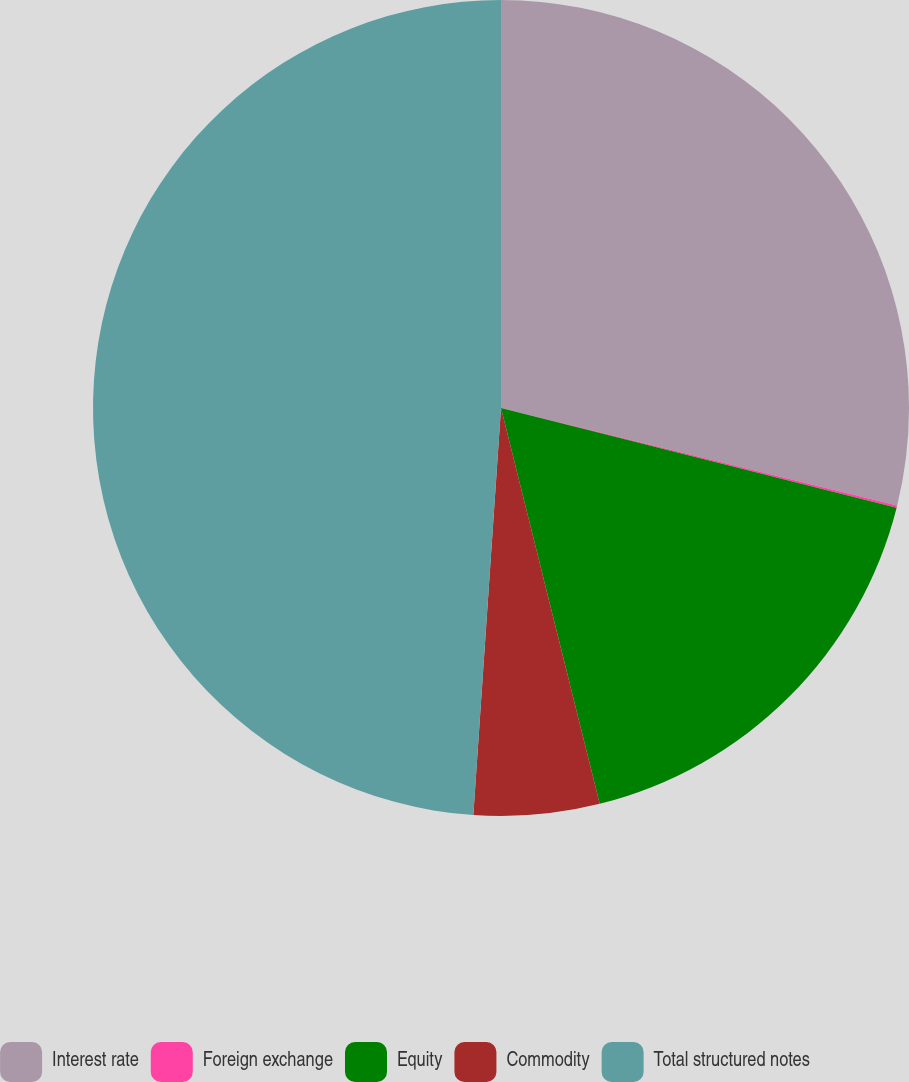Convert chart. <chart><loc_0><loc_0><loc_500><loc_500><pie_chart><fcel>Interest rate<fcel>Foreign exchange<fcel>Equity<fcel>Commodity<fcel>Total structured notes<nl><fcel>28.84%<fcel>0.09%<fcel>17.18%<fcel>4.97%<fcel>48.92%<nl></chart> 